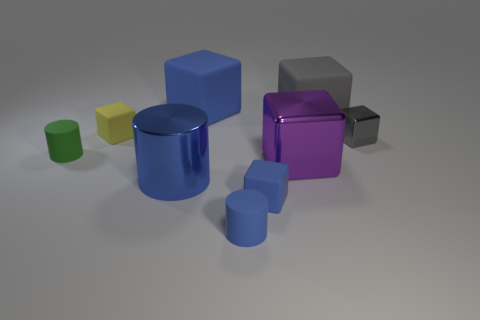What is the small blue thing that is in front of the blue block in front of the gray rubber object made of?
Give a very brief answer. Rubber. What number of yellow matte things have the same shape as the large purple shiny object?
Provide a short and direct response. 1. There is a blue object behind the big metallic block that is to the right of the large blue thing behind the big metallic cylinder; what is its size?
Make the answer very short. Large. How many green objects are big blocks or small matte blocks?
Make the answer very short. 0. There is a large thing behind the big gray rubber thing; is its shape the same as the large gray object?
Provide a succinct answer. Yes. Is the number of blue matte blocks in front of the gray metallic thing greater than the number of big yellow objects?
Offer a very short reply. Yes. What number of green rubber objects have the same size as the yellow thing?
Offer a very short reply. 1. What size is the other cylinder that is the same color as the big cylinder?
Keep it short and to the point. Small. How many things are shiny cylinders or tiny rubber cubes that are in front of the tiny green cylinder?
Provide a short and direct response. 2. There is a thing that is both behind the small yellow rubber cube and to the left of the purple metallic block; what is its color?
Ensure brevity in your answer.  Blue. 